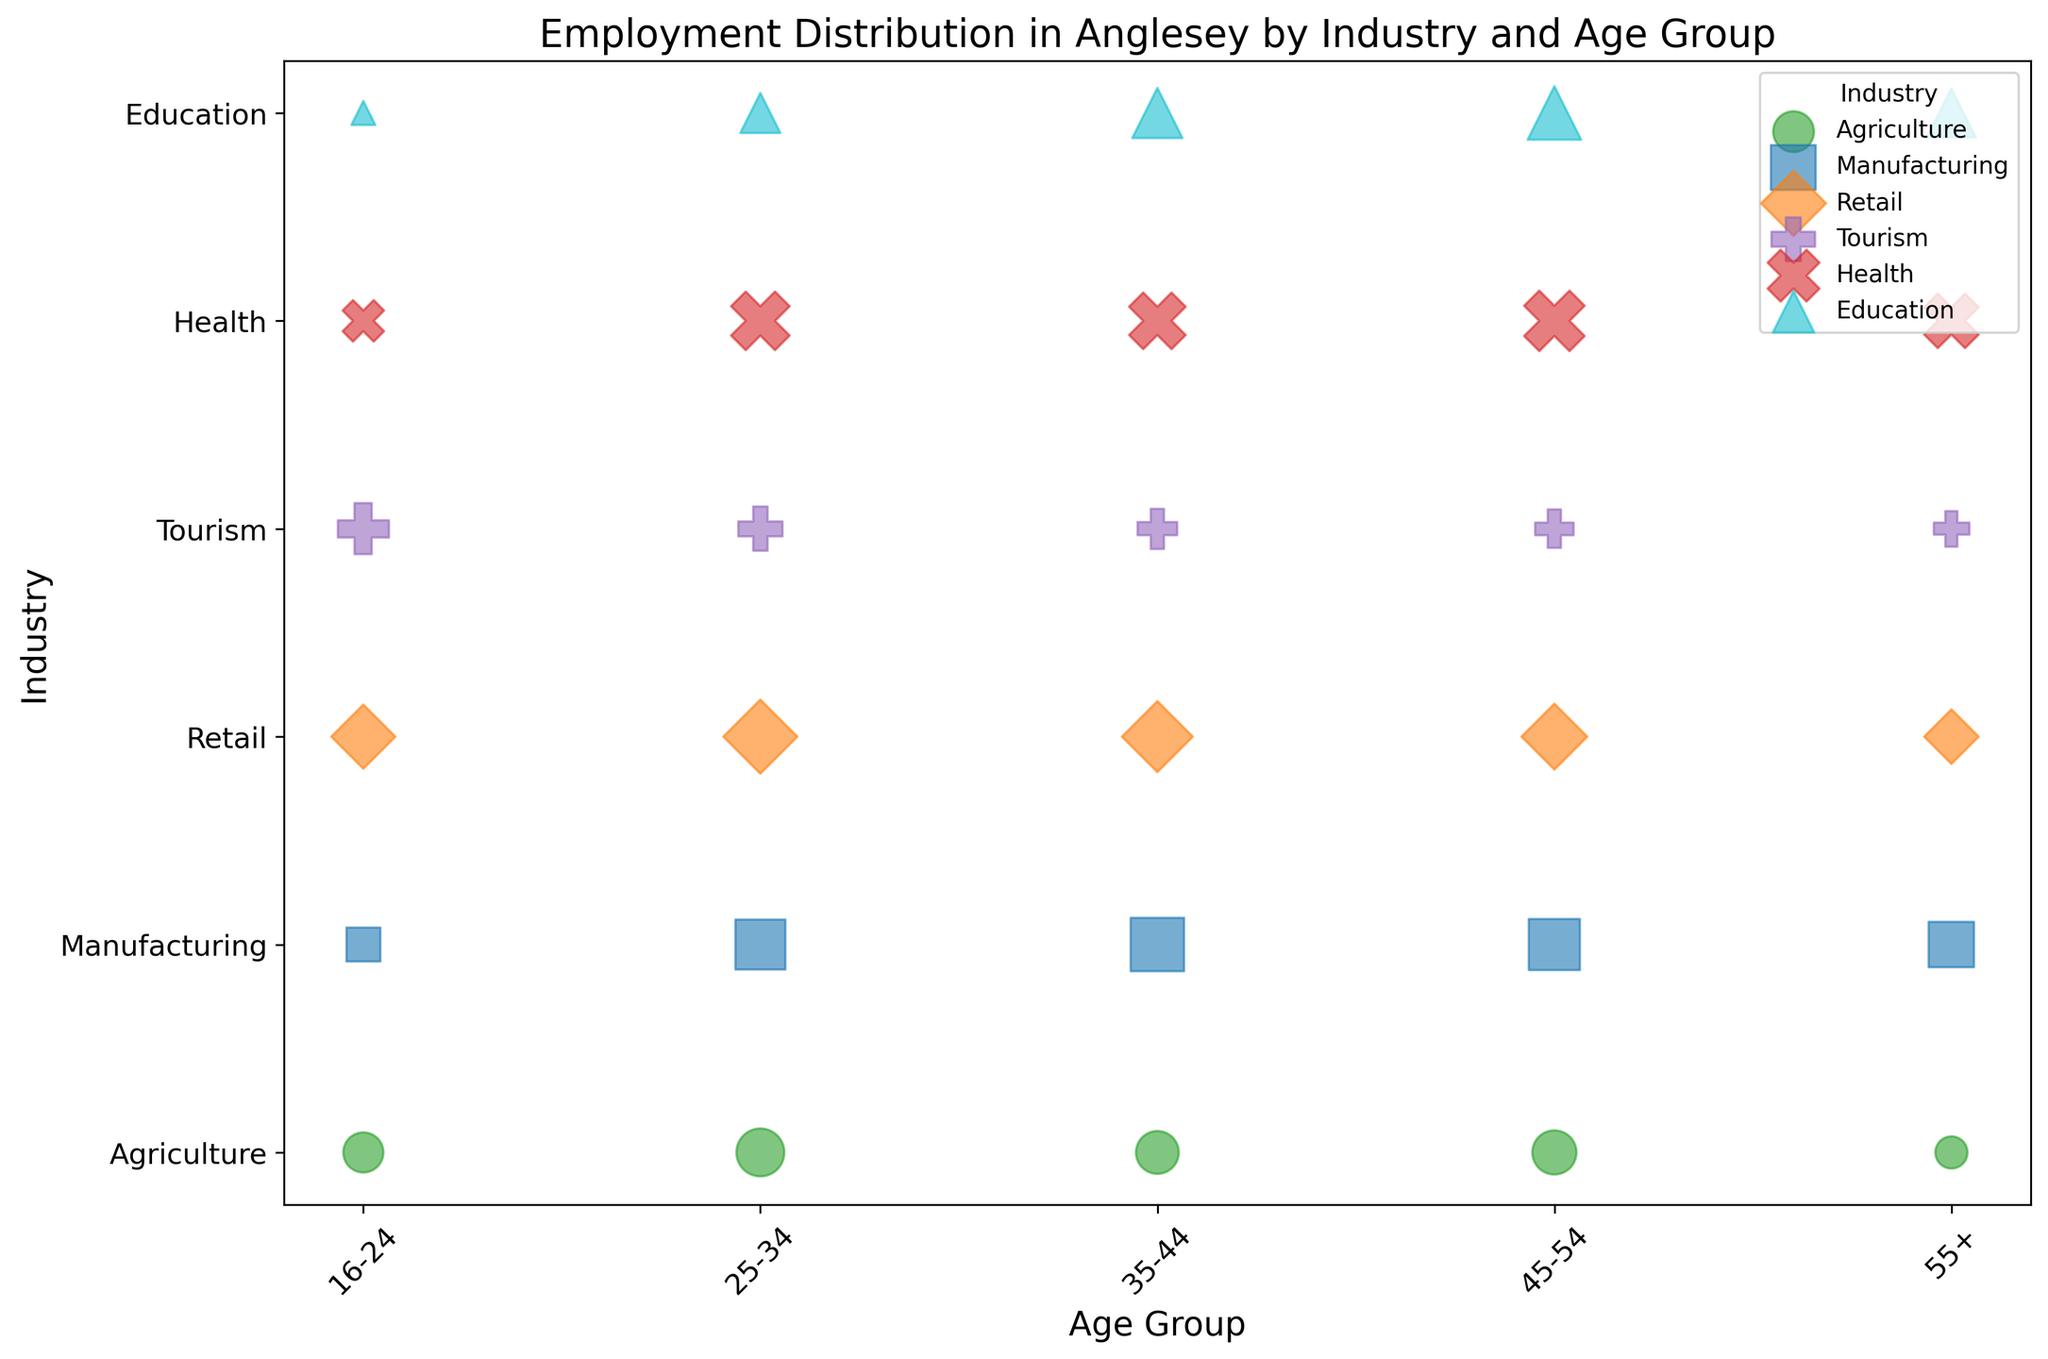What industry has the highest employment count in the 16-24 age group? By looking at the size of the bubbles, the largest bubble in the 16-24 age group corresponds to Tourism.
Answer: Tourism Which age group has the highest employment count in the Health industry? Observing the sizes of the bubbles in the Health row, the largest bubble is in the 45-54 age group.
Answer: 45-54 Compare the employment count in the Agriculture industry across the 25-34 and 35-44 age groups. Which has more? Comparing the sizes of the bubbles in the Agriculture row, the bubble for the 25-34 age group is larger than that for the 35-44 age group.
Answer: 25-34 What are the industries with the smallest employment count in the 55+ age group? The smallest bubbles for the 55+ age group are in Agriculture and Tourism.
Answer: Agriculture, Tourism What is the average employment count for the Education industry across all age groups? Add the employment counts for Education across all age groups (50, 140, 220, 250, 210) and divide by the number of age groups (5): (50 + 140 + 220 + 250 + 210) / 5 = 870 / 5 = 174.
Answer: 174 Which industry has the most uniform distribution of employment counts across all age groups? By observing the consistent sized bubbles across age groups, Manufacturing has relatively uniform employment counts.
Answer: Manufacturing What is the total employment count for the Retail industry? Summing up the employment counts in Retail across all age groups: 180 + 240 + 220 + 190 + 130 = 960.
Answer: 960 In which industry does the 25-34 age group have a higher employment count than the 35-44 age group? Comparing the sizes of the bubbles in the 25-34 and 35-44 age groups for each industry, this is true for Tourism where 170 > 140.
Answer: Tourism Which industry shows a significant drop in employment count as the age group increases to 55+? Looking at the difference in bubble sizes for the 55+ age group, the Agriculture industry shows a significant drop.
Answer: Agriculture 